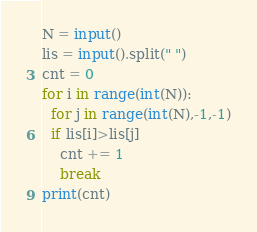<code> <loc_0><loc_0><loc_500><loc_500><_Python_>N = input()
lis = input().split(" ")
cnt = 0
for i in range(int(N)):
  for j in range(int(N),-1,-1)
  if lis[i]>lis[j]
    cnt += 1
    break
print(cnt)
</code> 